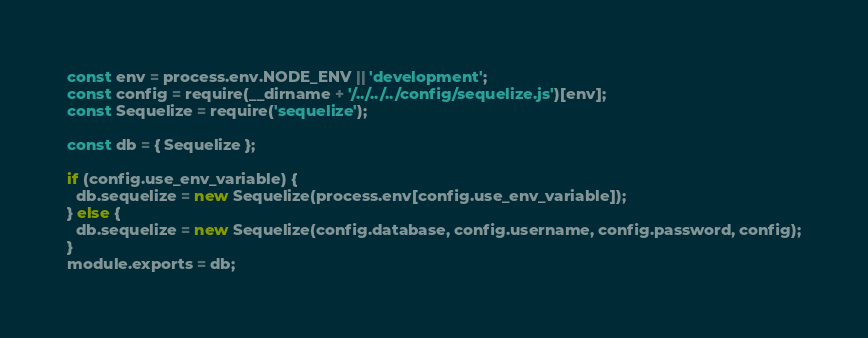Convert code to text. <code><loc_0><loc_0><loc_500><loc_500><_JavaScript_>const env = process.env.NODE_ENV || 'development';
const config = require(__dirname + '/../../../config/sequelize.js')[env];
const Sequelize = require('sequelize');

const db = { Sequelize };

if (config.use_env_variable) {
  db.sequelize = new Sequelize(process.env[config.use_env_variable]);
} else {
  db.sequelize = new Sequelize(config.database, config.username, config.password, config);
}
module.exports = db;
</code> 